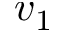<formula> <loc_0><loc_0><loc_500><loc_500>v _ { 1 }</formula> 